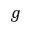Convert formula to latex. <formula><loc_0><loc_0><loc_500><loc_500>g</formula> 